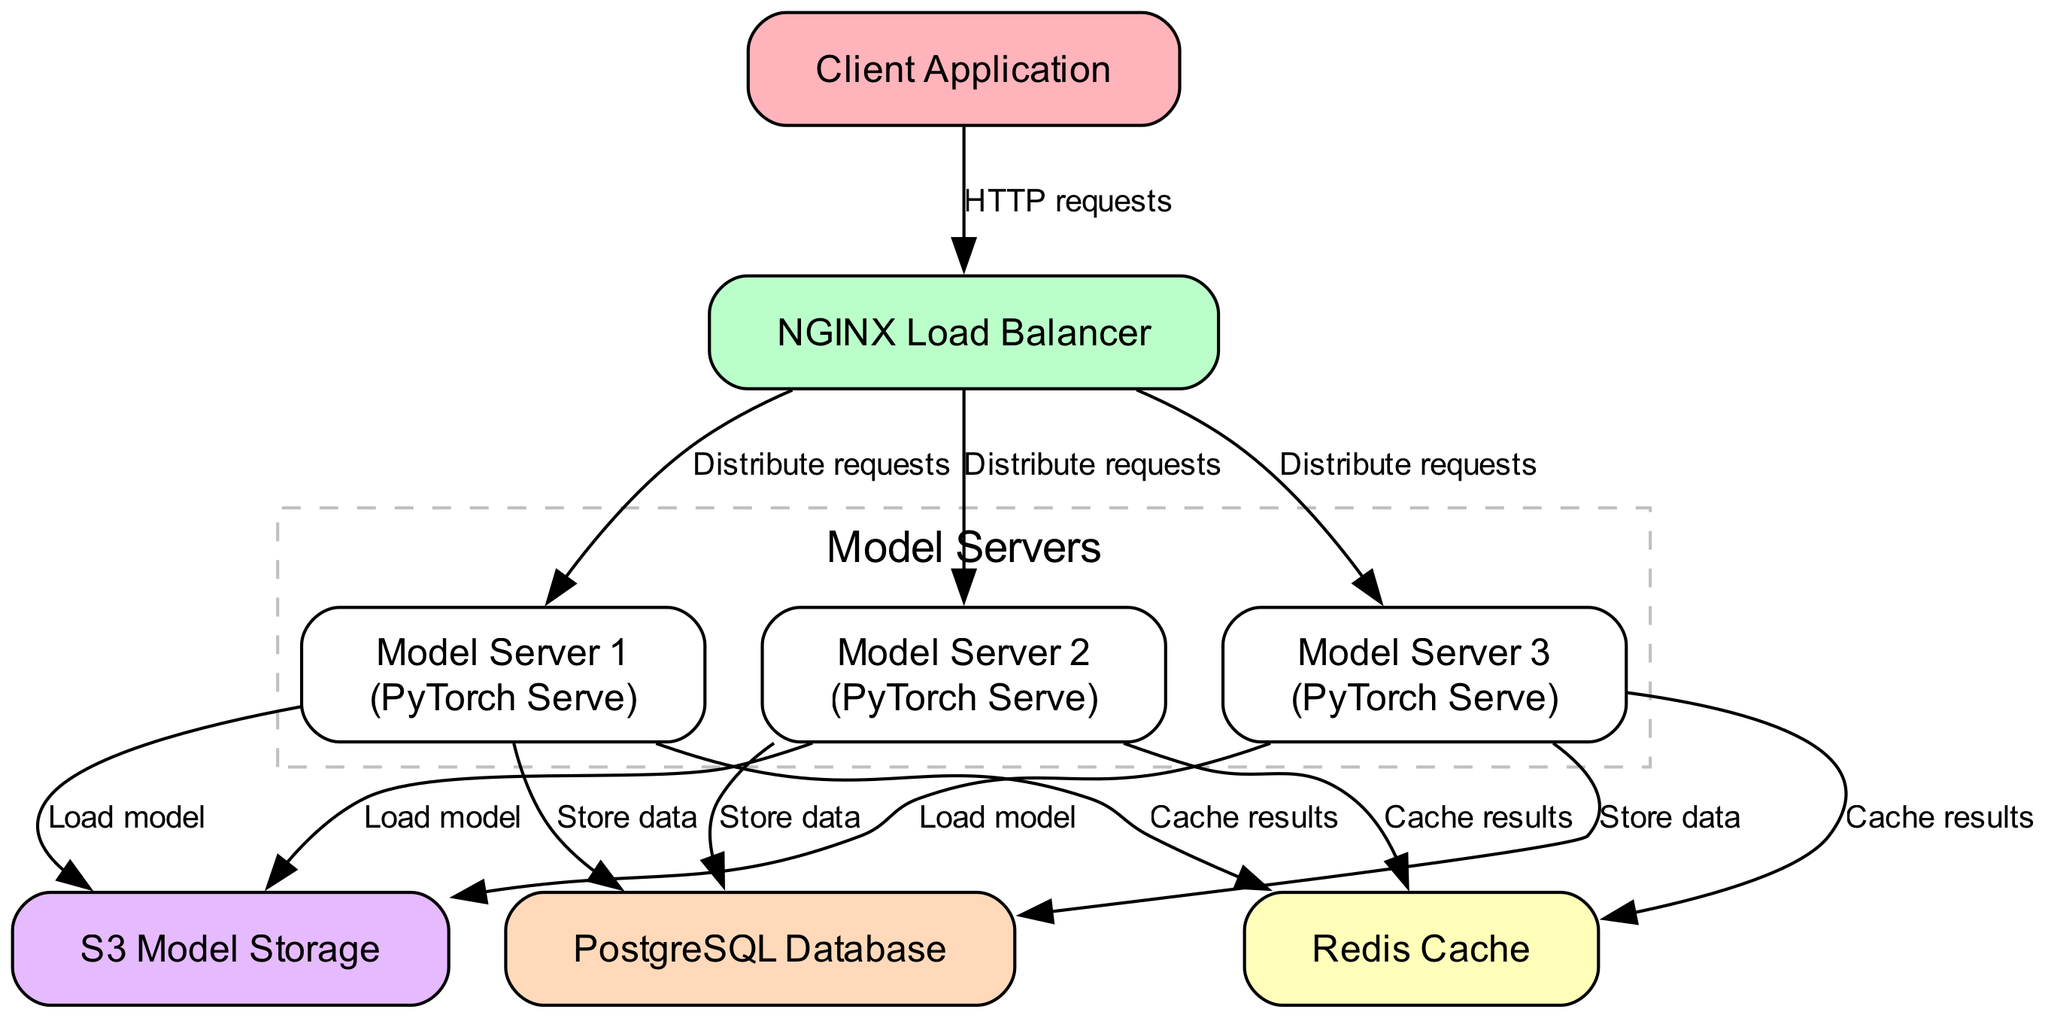What is the label of the load balancer node? The load balancer node is labeled as "NGINX Load Balancer" in the diagram.
Answer: NGINX Load Balancer How many model servers are depicted in the diagram? The diagram shows a total of three model servers: Model Server 1, Model Server 2, and Model Server 3.
Answer: 3 What type of requests does the client application send? The arrows from the client application to the load balancer indicate that the client sends "HTTP requests".
Answer: HTTP requests Which component stores data from the model servers? The edges from each of the model servers to the PostgreSQL Database indicate that this component is responsible for storing data.
Answer: PostgreSQL Database From which storage component do the model servers load the model? Each model server connects to the S3 storage component, as indicated by the edges that label it as "Load model".
Answer: S3 Model Storage What is the purpose of the Redis Cache in this deployment? The Redis Cache is utilized by model servers to "Cache results," as indicated by the edges connecting them to the cache.
Answer: Cache results Which node is responsible for distributing requests to the model servers? The NGINX Load Balancer node distributes requests to the three model servers based on the edges labeled "Distribute requests".
Answer: NGINX Load Balancer How many edges connect the model servers to the Redis Cache? Each of the three model servers has a directed edge that connects to the Redis Cache, totaling three edges.
Answer: 3 What labels are shown for Model Server 1 in the diagram? Model Server 1 is labeled as "Model Server 1\n(PyTorch Serve)", indicating both its identifier and implementation technology.
Answer: Model Server 1 (PyTorch Serve) Which component does not receive data directly from the client application? The S3 Model Storage does not receive data directly from the client; it is accessed by the model servers, making it the one not connected to the client.
Answer: S3 Model Storage 